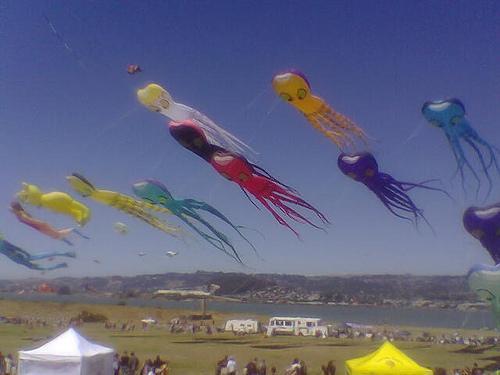How many kites are in the picture?
Give a very brief answer. 6. How many bikes are there?
Give a very brief answer. 0. 